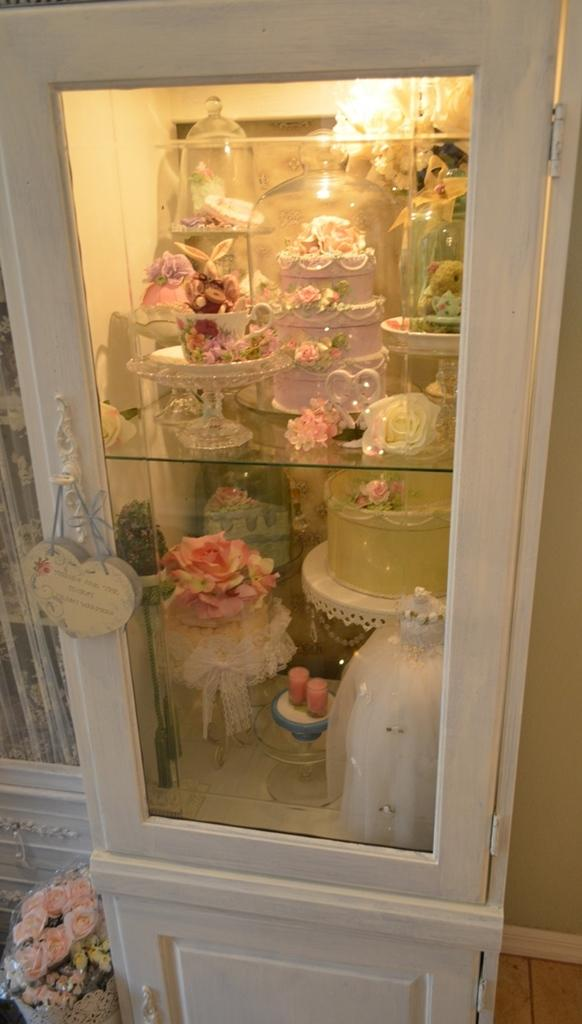What is located in the center of the image? There is a shelf in the center of the image. What can be found on the shelf? There are many objects on the shelf. What type of canvas is visible on the shelf in the image? There is no canvas present on the shelf in the image. Where is the drain located in the image? There is no drain present in the image. 